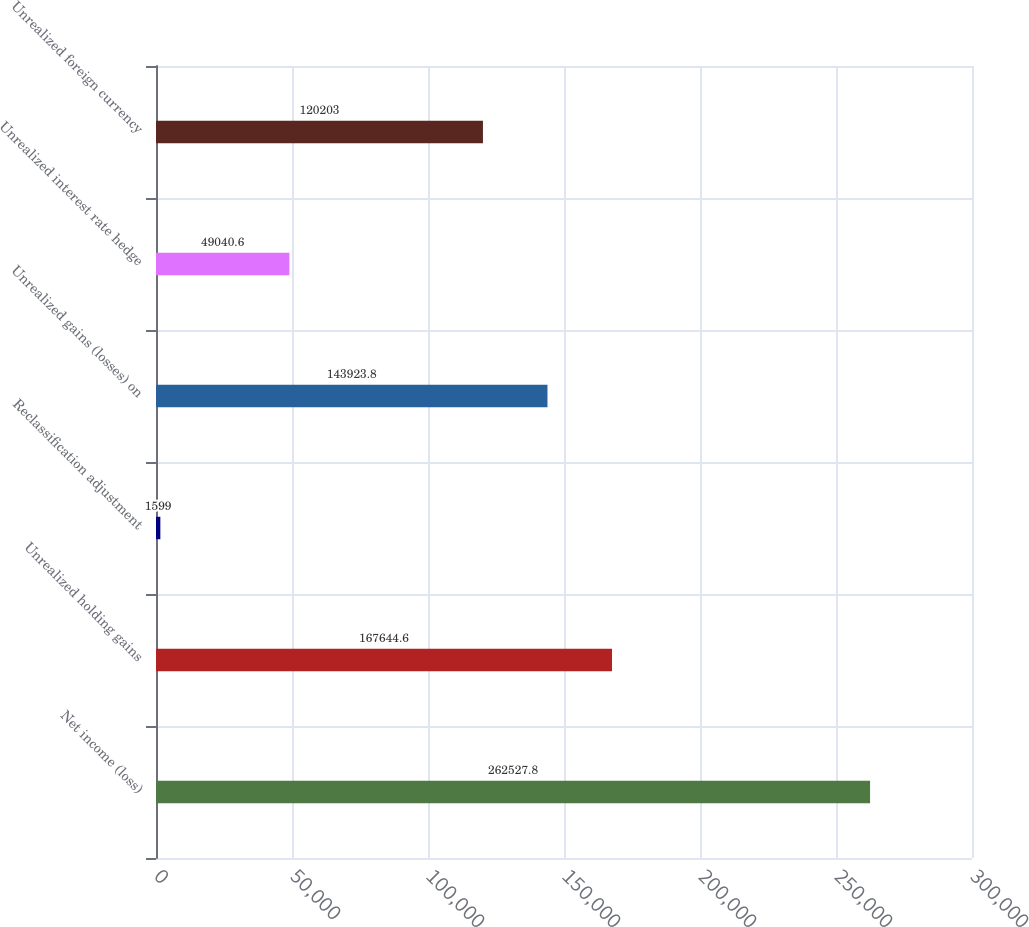<chart> <loc_0><loc_0><loc_500><loc_500><bar_chart><fcel>Net income (loss)<fcel>Unrealized holding gains<fcel>Reclassification adjustment<fcel>Unrealized gains (losses) on<fcel>Unrealized interest rate hedge<fcel>Unrealized foreign currency<nl><fcel>262528<fcel>167645<fcel>1599<fcel>143924<fcel>49040.6<fcel>120203<nl></chart> 